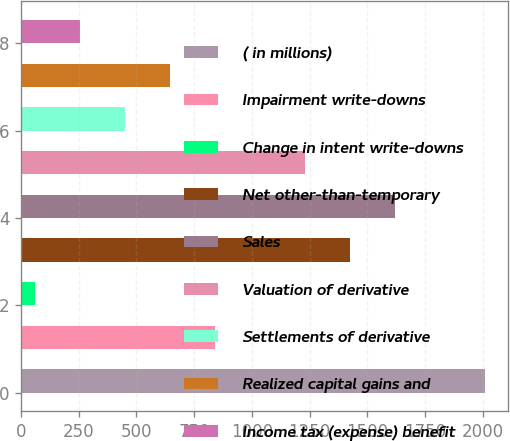Convert chart. <chart><loc_0><loc_0><loc_500><loc_500><bar_chart><fcel>( in millions)<fcel>Impairment write-downs<fcel>Change in intent write-downs<fcel>Net other-than-temporary<fcel>Sales<fcel>Valuation of derivative<fcel>Settlements of derivative<fcel>Realized capital gains and<fcel>Income tax (expense) benefit<nl><fcel>2010<fcel>841.2<fcel>62<fcel>1425.6<fcel>1620.4<fcel>1230.8<fcel>451.6<fcel>646.4<fcel>256.8<nl></chart> 